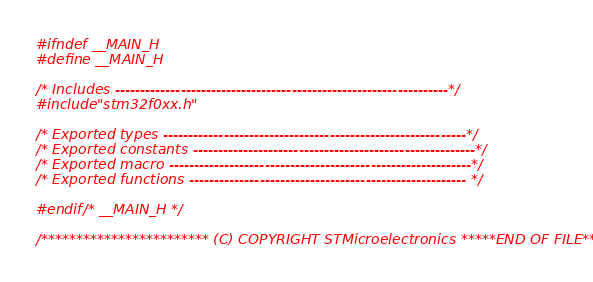Convert code to text. <code><loc_0><loc_0><loc_500><loc_500><_C_>#ifndef __MAIN_H
#define __MAIN_H

/* Includes ------------------------------------------------------------------*/
#include "stm32f0xx.h"

/* Exported types ------------------------------------------------------------*/
/* Exported constants --------------------------------------------------------*/
/* Exported macro ------------------------------------------------------------*/
/* Exported functions ------------------------------------------------------- */

#endif /* __MAIN_H */

/************************ (C) COPYRIGHT STMicroelectronics *****END OF FILE****/
</code> 